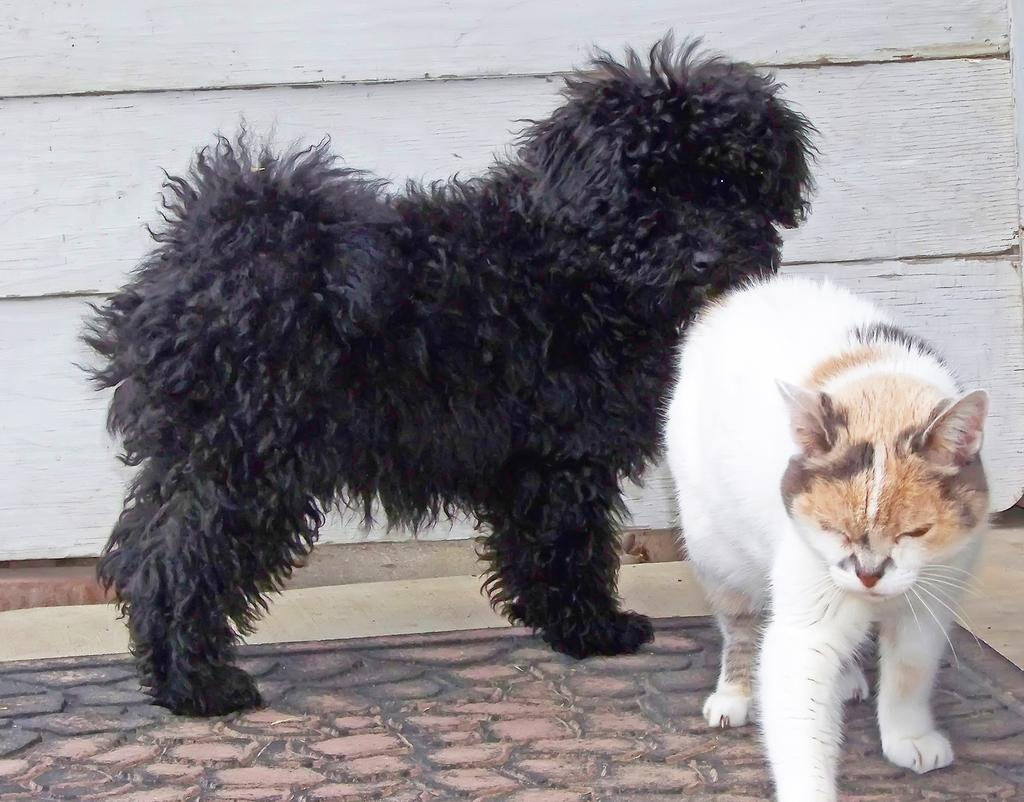What animals are present in the image? There is a dog and a cat in the image. What are the positions of the dog and the cat in the image? Both the dog and the cat are standing on the floor. What is visible in the background of the image? There is a wall in the background of the image. What type of net is being used by the dog in the image? There is no net present in the image, and the dog is not using any net. What channel might be playing on the television in the image? There is no television present in the image, so it is not possible to determine what channel might be playing. --- Facts: 1. There is a person holding a camera in the image. 2. The person is standing on a bridge. 3. There is a river visible below the bridge. 4. The sky is visible in the background of the image. Absurd Topics: cake, balloon, dance Conversation: What is the person in the image holding? The person in the image is holding a camera. Where is the person standing in the image? The person is standing on a bridge. What is visible below the bridge in the image? There is a river visible below the bridge. What is visible in the background of the image? The sky is visible in the background of the image. Reasoning: Let's think step by step in order to produce the conversation. We start by identifying the main subject in the image, which is the person holding a camera. Then, we describe the location of the person, noting that they are standing on a bridge. Next, we describe what is visible below the bridge, which is a river. Finally, we describe the background of the image, which includes the sky. Absurd Question/Answer: What type of cake is being served on the bridge in the image? There is no cake present in the image, and therefore no such activity can be observed. What color is the balloon tied to the railing of the bridge in the image? There is no balloon present in the image, so it is not possible to determine its color. 